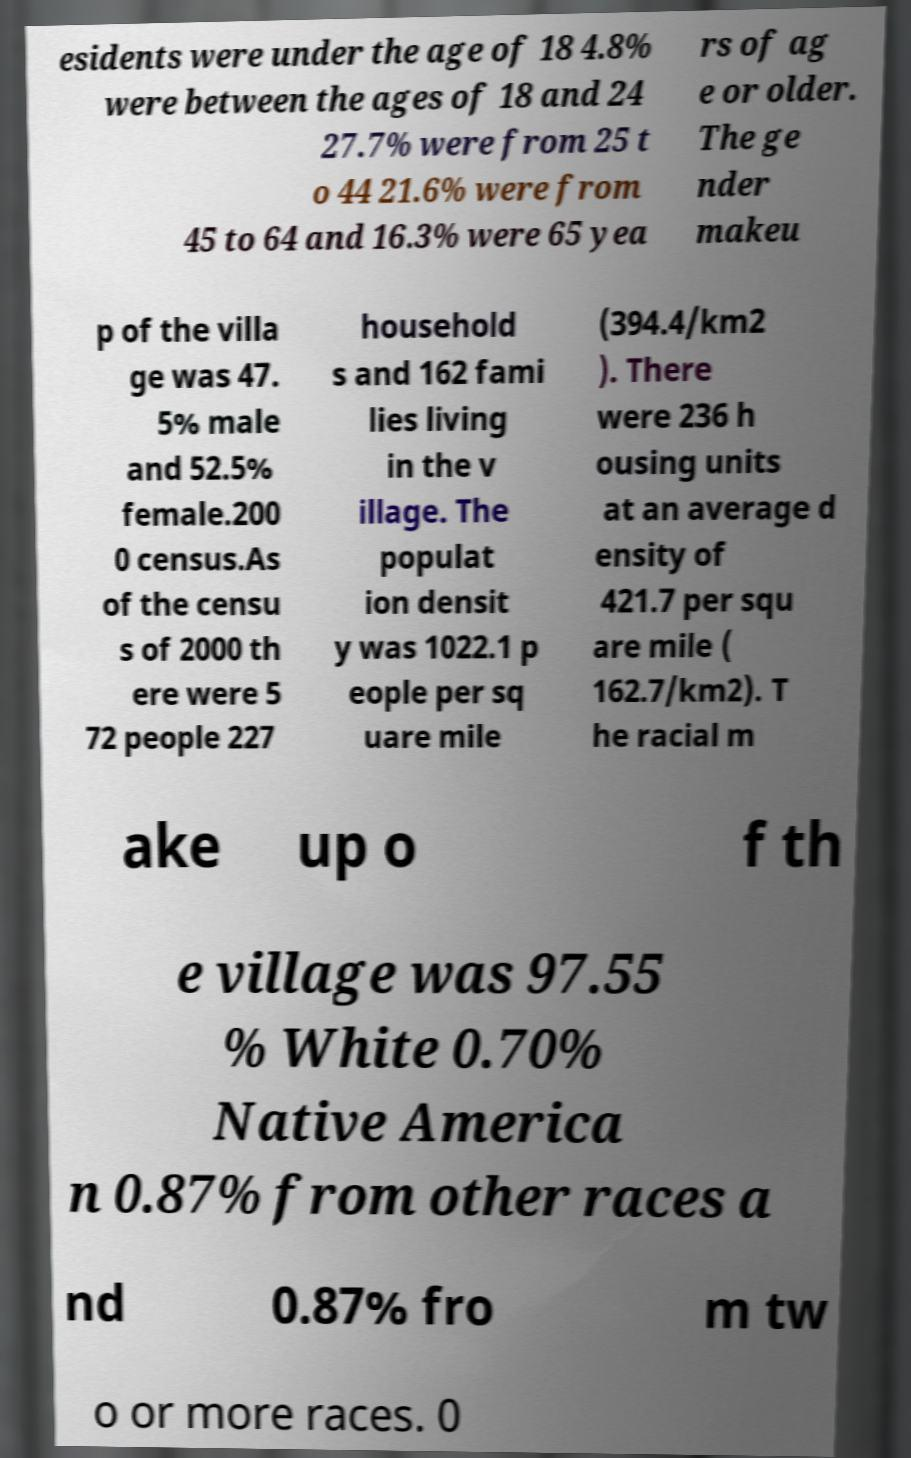Please read and relay the text visible in this image. What does it say? esidents were under the age of 18 4.8% were between the ages of 18 and 24 27.7% were from 25 t o 44 21.6% were from 45 to 64 and 16.3% were 65 yea rs of ag e or older. The ge nder makeu p of the villa ge was 47. 5% male and 52.5% female.200 0 census.As of the censu s of 2000 th ere were 5 72 people 227 household s and 162 fami lies living in the v illage. The populat ion densit y was 1022.1 p eople per sq uare mile (394.4/km2 ). There were 236 h ousing units at an average d ensity of 421.7 per squ are mile ( 162.7/km2). T he racial m ake up o f th e village was 97.55 % White 0.70% Native America n 0.87% from other races a nd 0.87% fro m tw o or more races. 0 